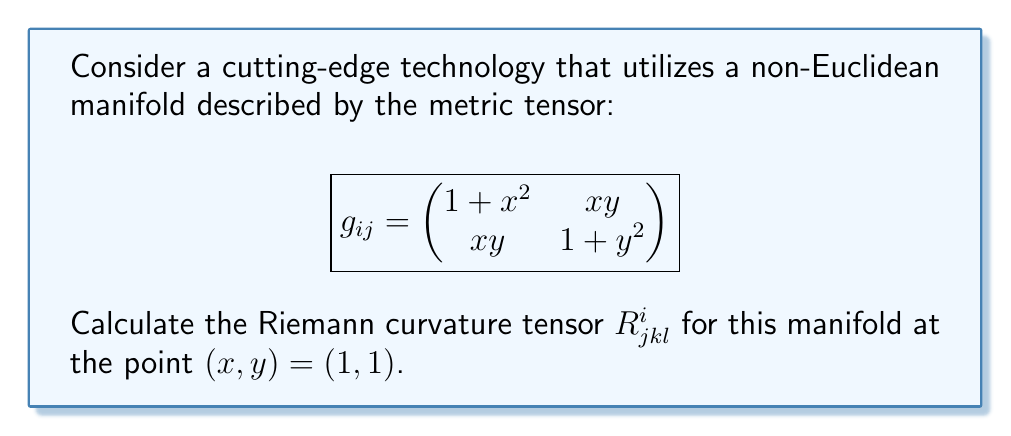Help me with this question. To calculate the Riemann curvature tensor, we'll follow these steps:

1) First, we need to calculate the Christoffel symbols $\Gamma^i_{jk}$ using the formula:

   $$\Gamma^i_{jk} = \frac{1}{2}g^{im}(\partial_j g_{km} + \partial_k g_{jm} - \partial_m g_{jk})$$

2) Calculate the inverse metric tensor $g^{ij}$:

   $$g^{ij} = \frac{1}{\det(g_{ij})} \begin{pmatrix}
   1 + y^2 & -xy \\
   -xy & 1 + x^2
   \end{pmatrix}$$

   At $(1, 1)$, $\det(g_{ij}) = (1+1^2)(1+1^2) - 1^2 = 3$, so:

   $$g^{ij} = \frac{1}{3} \begin{pmatrix}
   2 & -1 \\
   -1 & 2
   \end{pmatrix}$$

3) Calculate the partial derivatives of $g_{ij}$:

   $$\partial_x g_{11} = 2x, \partial_y g_{11} = 0$$
   $$\partial_x g_{12} = y, \partial_y g_{12} = x$$
   $$\partial_x g_{22} = 0, \partial_y g_{22} = 2y$$

4) Calculate the Christoffel symbols at $(1, 1)$:

   $$\Gamma^1_{11} = \frac{1}{3}(2 \cdot 2 - 1 \cdot 0) = \frac{4}{3}$$
   $$\Gamma^1_{12} = \Gamma^1_{21} = \frac{1}{3}(2 \cdot 1 - 1 \cdot 1) = \frac{1}{3}$$
   $$\Gamma^1_{22} = \frac{1}{3}(2 \cdot 0 - 1 \cdot 2) = -\frac{2}{3}$$
   $$\Gamma^2_{11} = \frac{1}{3}(-1 \cdot 2 - 1 \cdot 0) = -\frac{2}{3}$$
   $$\Gamma^2_{12} = \Gamma^2_{21} = \frac{1}{3}(-1 \cdot 1 - 1 \cdot 1) = -\frac{2}{3}$$
   $$\Gamma^2_{22} = \frac{1}{3}(-1 \cdot 0 + 2 \cdot 2) = \frac{4}{3}$$

5) Now, we can calculate the Riemann curvature tensor using:

   $$R^i_{jkl} = \partial_k \Gamma^i_{jl} - \partial_l \Gamma^i_{jk} + \Gamma^m_{jl}\Gamma^i_{km} - \Gamma^m_{jk}\Gamma^i_{lm}$$

   Due to symmetries, we only need to calculate $R^1_{212}$ and $R^2_{121}$:

   $$R^1_{212} = \partial_1 \Gamma^1_{22} - \partial_2 \Gamma^1_{21} + \Gamma^1_{22}\Gamma^1_{11} + \Gamma^2_{22}\Gamma^1_{12} - \Gamma^1_{21}\Gamma^1_{12} - \Gamma^2_{21}\Gamma^1_{22}$$
   
   $$R^1_{212} = 0 - 0 + (-\frac{2}{3})(\frac{4}{3}) + (\frac{4}{3})(\frac{1}{3}) - (\frac{1}{3})(\frac{1}{3}) - (-\frac{2}{3})(-\frac{2}{3}) = -\frac{8}{9} - \frac{4}{9} - \frac{1}{9} - \frac{4}{9} = -\frac{17}{9}$$

   $$R^2_{121} = \partial_2 \Gamma^2_{11} - \partial_1 \Gamma^2_{21} + \Gamma^1_{11}\Gamma^2_{21} + \Gamma^2_{11}\Gamma^2_{22} - \Gamma^1_{21}\Gamma^2_{11} - \Gamma^2_{21}\Gamma^2_{12}$$
   
   $$R^2_{121} = 0 - 0 + (\frac{4}{3})(-\frac{2}{3}) + (-\frac{2}{3})(\frac{4}{3}) - (\frac{1}{3})(-\frac{2}{3}) - (-\frac{2}{3})(-\frac{2}{3}) = -\frac{8}{9} - \frac{8}{9} + \frac{2}{9} - \frac{4}{9} = -2$$
Answer: $R^1_{212} = -\frac{17}{9}$, $R^2_{121} = -2$ 